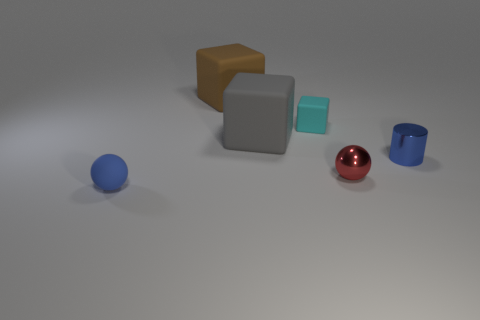What mood or atmosphere does the arrangement and choice of colors in this image convey? The image conveys a calm and neutral atmosphere. The muted colors, such as the soft blue, gentle brown, and subdued gray, along with the simple arrangement of objects against a minimalist background, evoke a sense of order and tranquility. The solitary red sphere introduces a touch of warmth and vitality, creating a subtle focal point without disrupting the overall serene mood of the composition. 